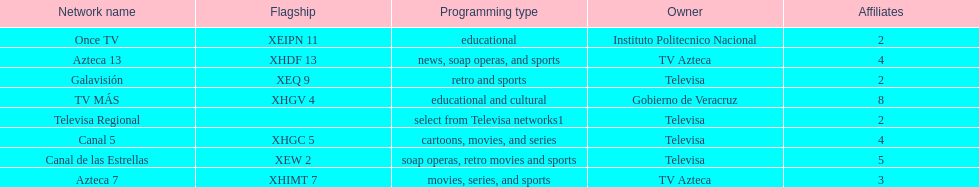Tell me the number of stations tv azteca owns. 2. 